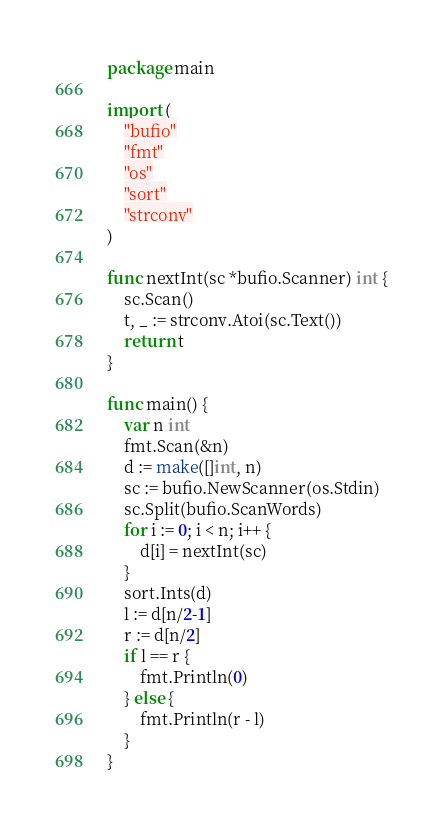<code> <loc_0><loc_0><loc_500><loc_500><_Go_>package main

import (
	"bufio"
	"fmt"
	"os"
	"sort"
	"strconv"
)

func nextInt(sc *bufio.Scanner) int {
	sc.Scan()
	t, _ := strconv.Atoi(sc.Text())
	return t
}

func main() {
	var n int
	fmt.Scan(&n)
	d := make([]int, n)
	sc := bufio.NewScanner(os.Stdin)
	sc.Split(bufio.ScanWords)
	for i := 0; i < n; i++ {
		d[i] = nextInt(sc)
	}
	sort.Ints(d)
	l := d[n/2-1]
	r := d[n/2]
	if l == r {
		fmt.Println(0)
	} else {
		fmt.Println(r - l)
	}
}
</code> 